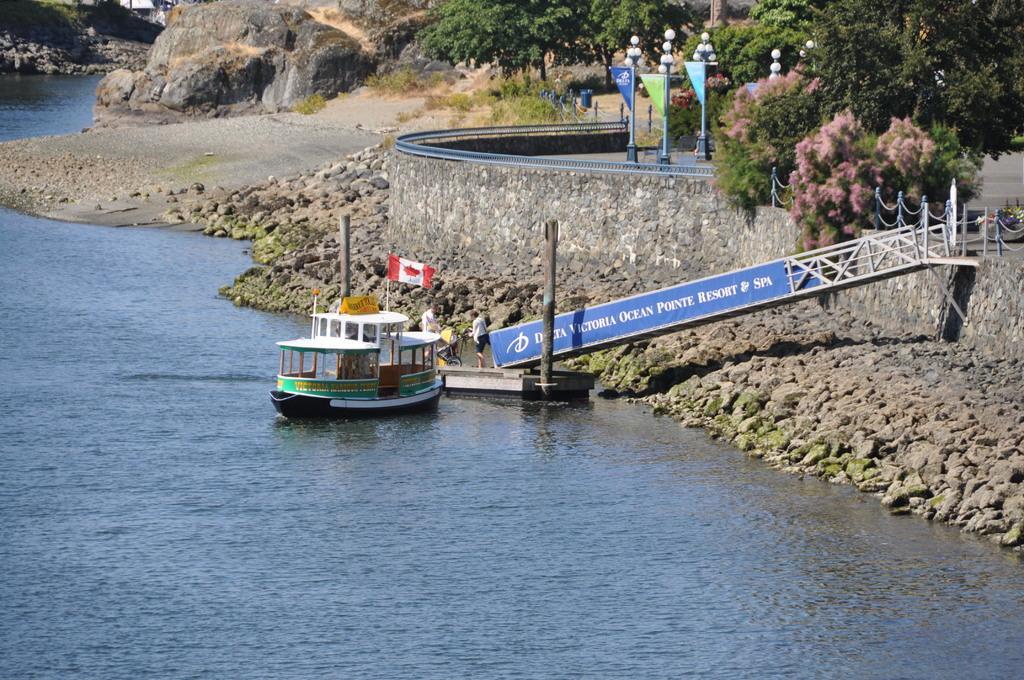In one or two sentences, can you explain what this image depicts? There is a flag on the boat which is on the water of a river near few persons standing on the another boat which is near a bridge. On the right side, there are stones at the wall. In the background, there are lights attached to the poles, there are flags, trees and there are mountains. 